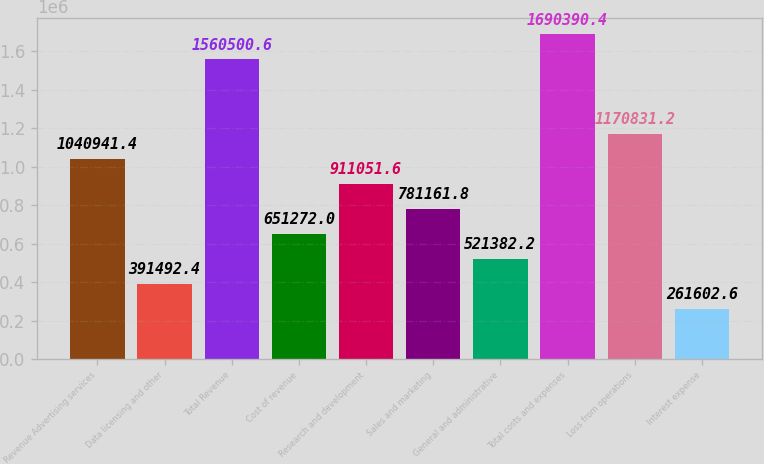Convert chart. <chart><loc_0><loc_0><loc_500><loc_500><bar_chart><fcel>Revenue Advertising services<fcel>Data licensing and other<fcel>Total Revenue<fcel>Cost of revenue<fcel>Research and development<fcel>Sales and marketing<fcel>General and administrative<fcel>Total costs and expenses<fcel>Loss from operations<fcel>Interest expense<nl><fcel>1.04094e+06<fcel>391492<fcel>1.5605e+06<fcel>651272<fcel>911052<fcel>781162<fcel>521382<fcel>1.69039e+06<fcel>1.17083e+06<fcel>261603<nl></chart> 